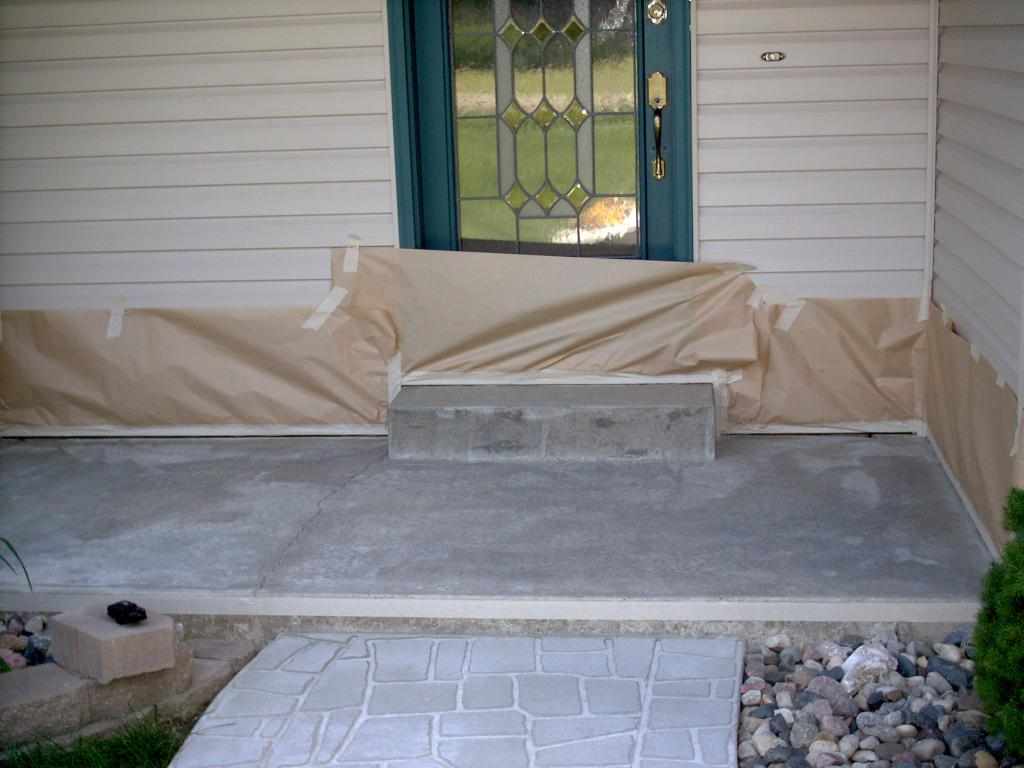What is the main subject in the center of the image? There is a door in the center of the image. What can be seen at the bottom side of the image? There are pebbles at the bottom side of the image. What type of structure does the image appear to depict? The image appears to depict a house. What type of table is visible in the image? There is no table present in the image. What kind of vessel is being used to transport the pebbles in the image? There is no vessel present in the image; the pebbles are simply depicted at the bottom side of the image. 